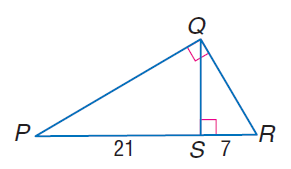Answer the mathemtical geometry problem and directly provide the correct option letter.
Question: Find the measure of the altitude drawn to the hypotenuse.
Choices: A: \sqrt { 3 } B: \sqrt { 7 } C: \sqrt { 21 } D: \sqrt { 147 } D 